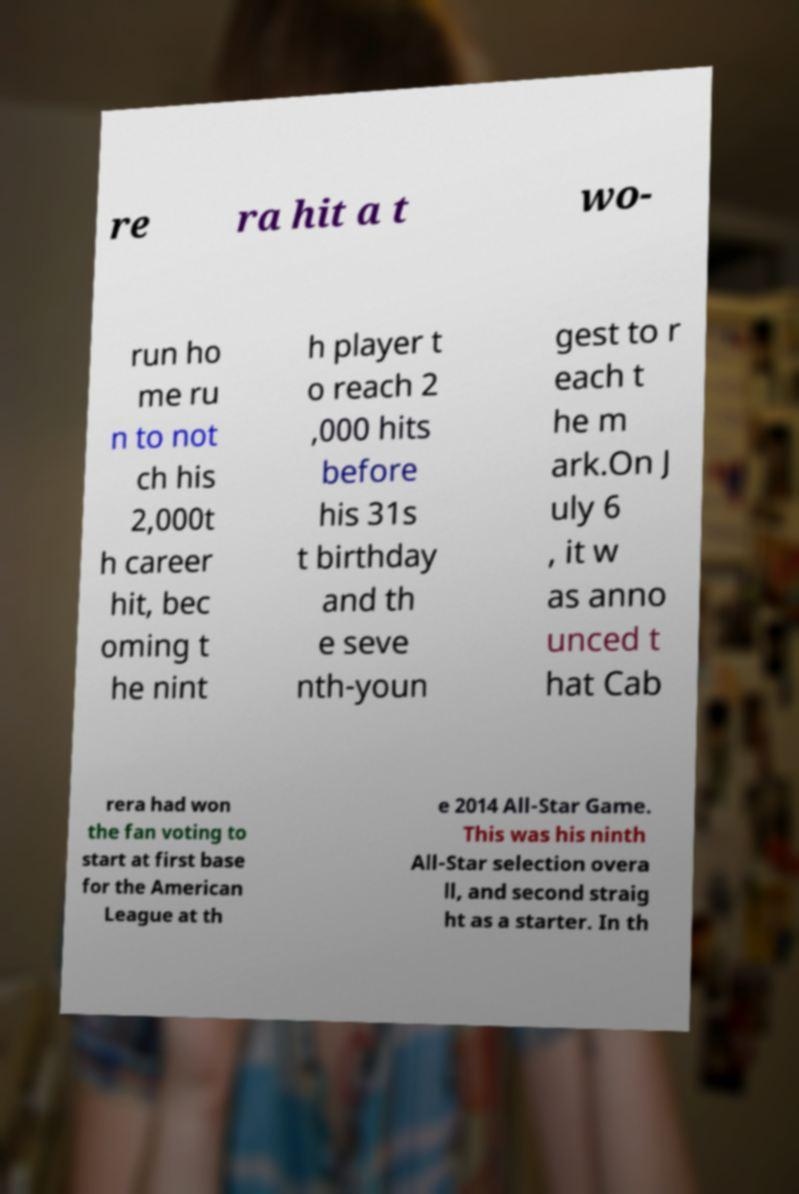What messages or text are displayed in this image? I need them in a readable, typed format. re ra hit a t wo- run ho me ru n to not ch his 2,000t h career hit, bec oming t he nint h player t o reach 2 ,000 hits before his 31s t birthday and th e seve nth-youn gest to r each t he m ark.On J uly 6 , it w as anno unced t hat Cab rera had won the fan voting to start at first base for the American League at th e 2014 All-Star Game. This was his ninth All-Star selection overa ll, and second straig ht as a starter. In th 